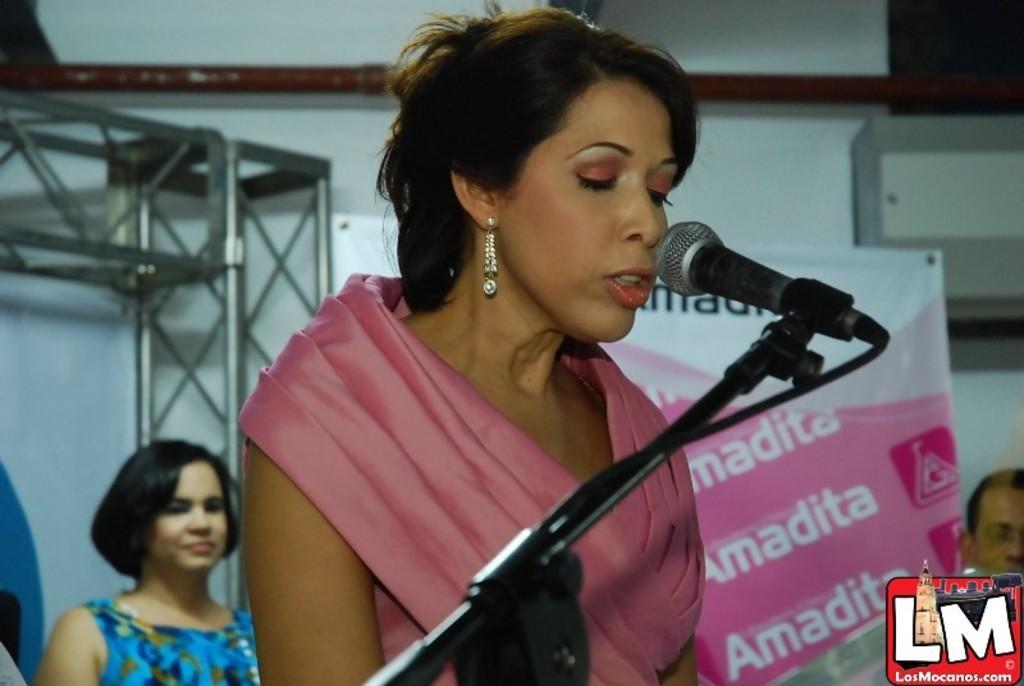Can you describe this image briefly? In this image I can see a woman is speaking on the mike by looking at the downwards. On the left side, I can see another woman who is wearing blue color dress. At the back of her I can see a metal stand. In the background there is a white color banner, beside that I can see a person's head. On the top of the image I can see a wall. On the right bottom of the image I can see a logo. 